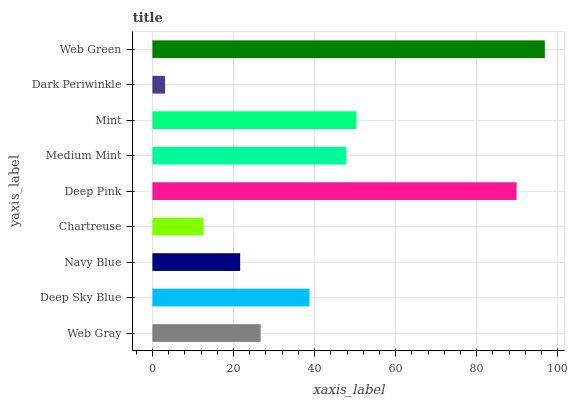Is Dark Periwinkle the minimum?
Answer yes or no. Yes. Is Web Green the maximum?
Answer yes or no. Yes. Is Deep Sky Blue the minimum?
Answer yes or no. No. Is Deep Sky Blue the maximum?
Answer yes or no. No. Is Deep Sky Blue greater than Web Gray?
Answer yes or no. Yes. Is Web Gray less than Deep Sky Blue?
Answer yes or no. Yes. Is Web Gray greater than Deep Sky Blue?
Answer yes or no. No. Is Deep Sky Blue less than Web Gray?
Answer yes or no. No. Is Deep Sky Blue the high median?
Answer yes or no. Yes. Is Deep Sky Blue the low median?
Answer yes or no. Yes. Is Web Gray the high median?
Answer yes or no. No. Is Medium Mint the low median?
Answer yes or no. No. 